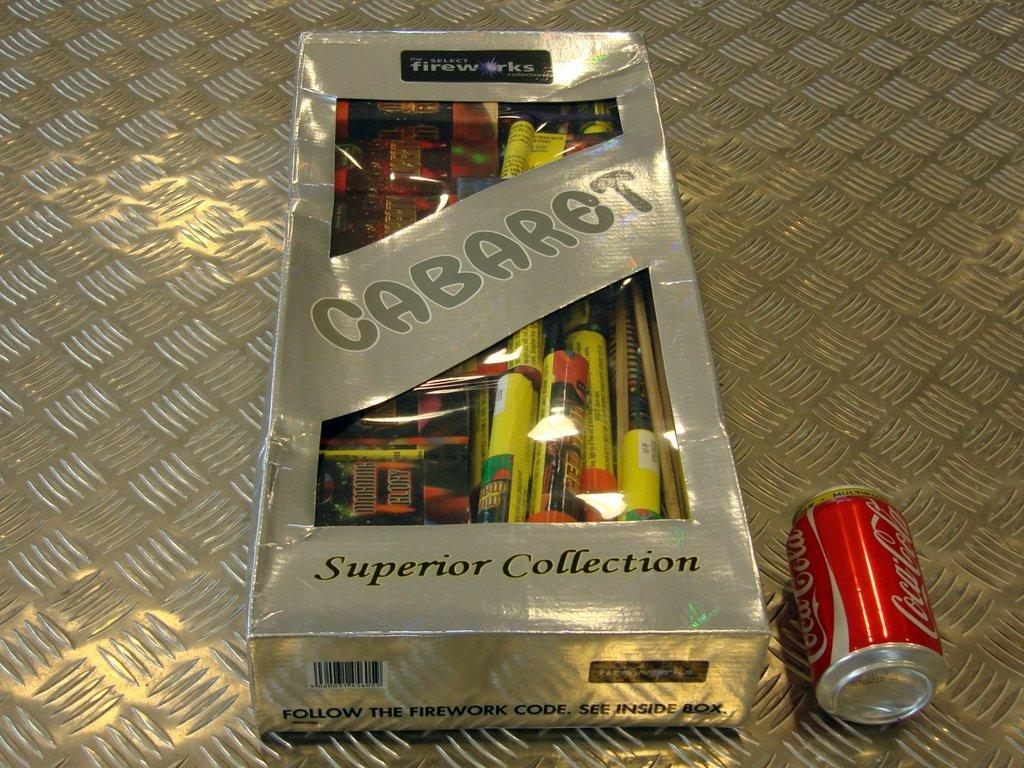Provide a one-sentence caption for the provided image. A large box of Cabaret fireworks sits next to a Coke can. 